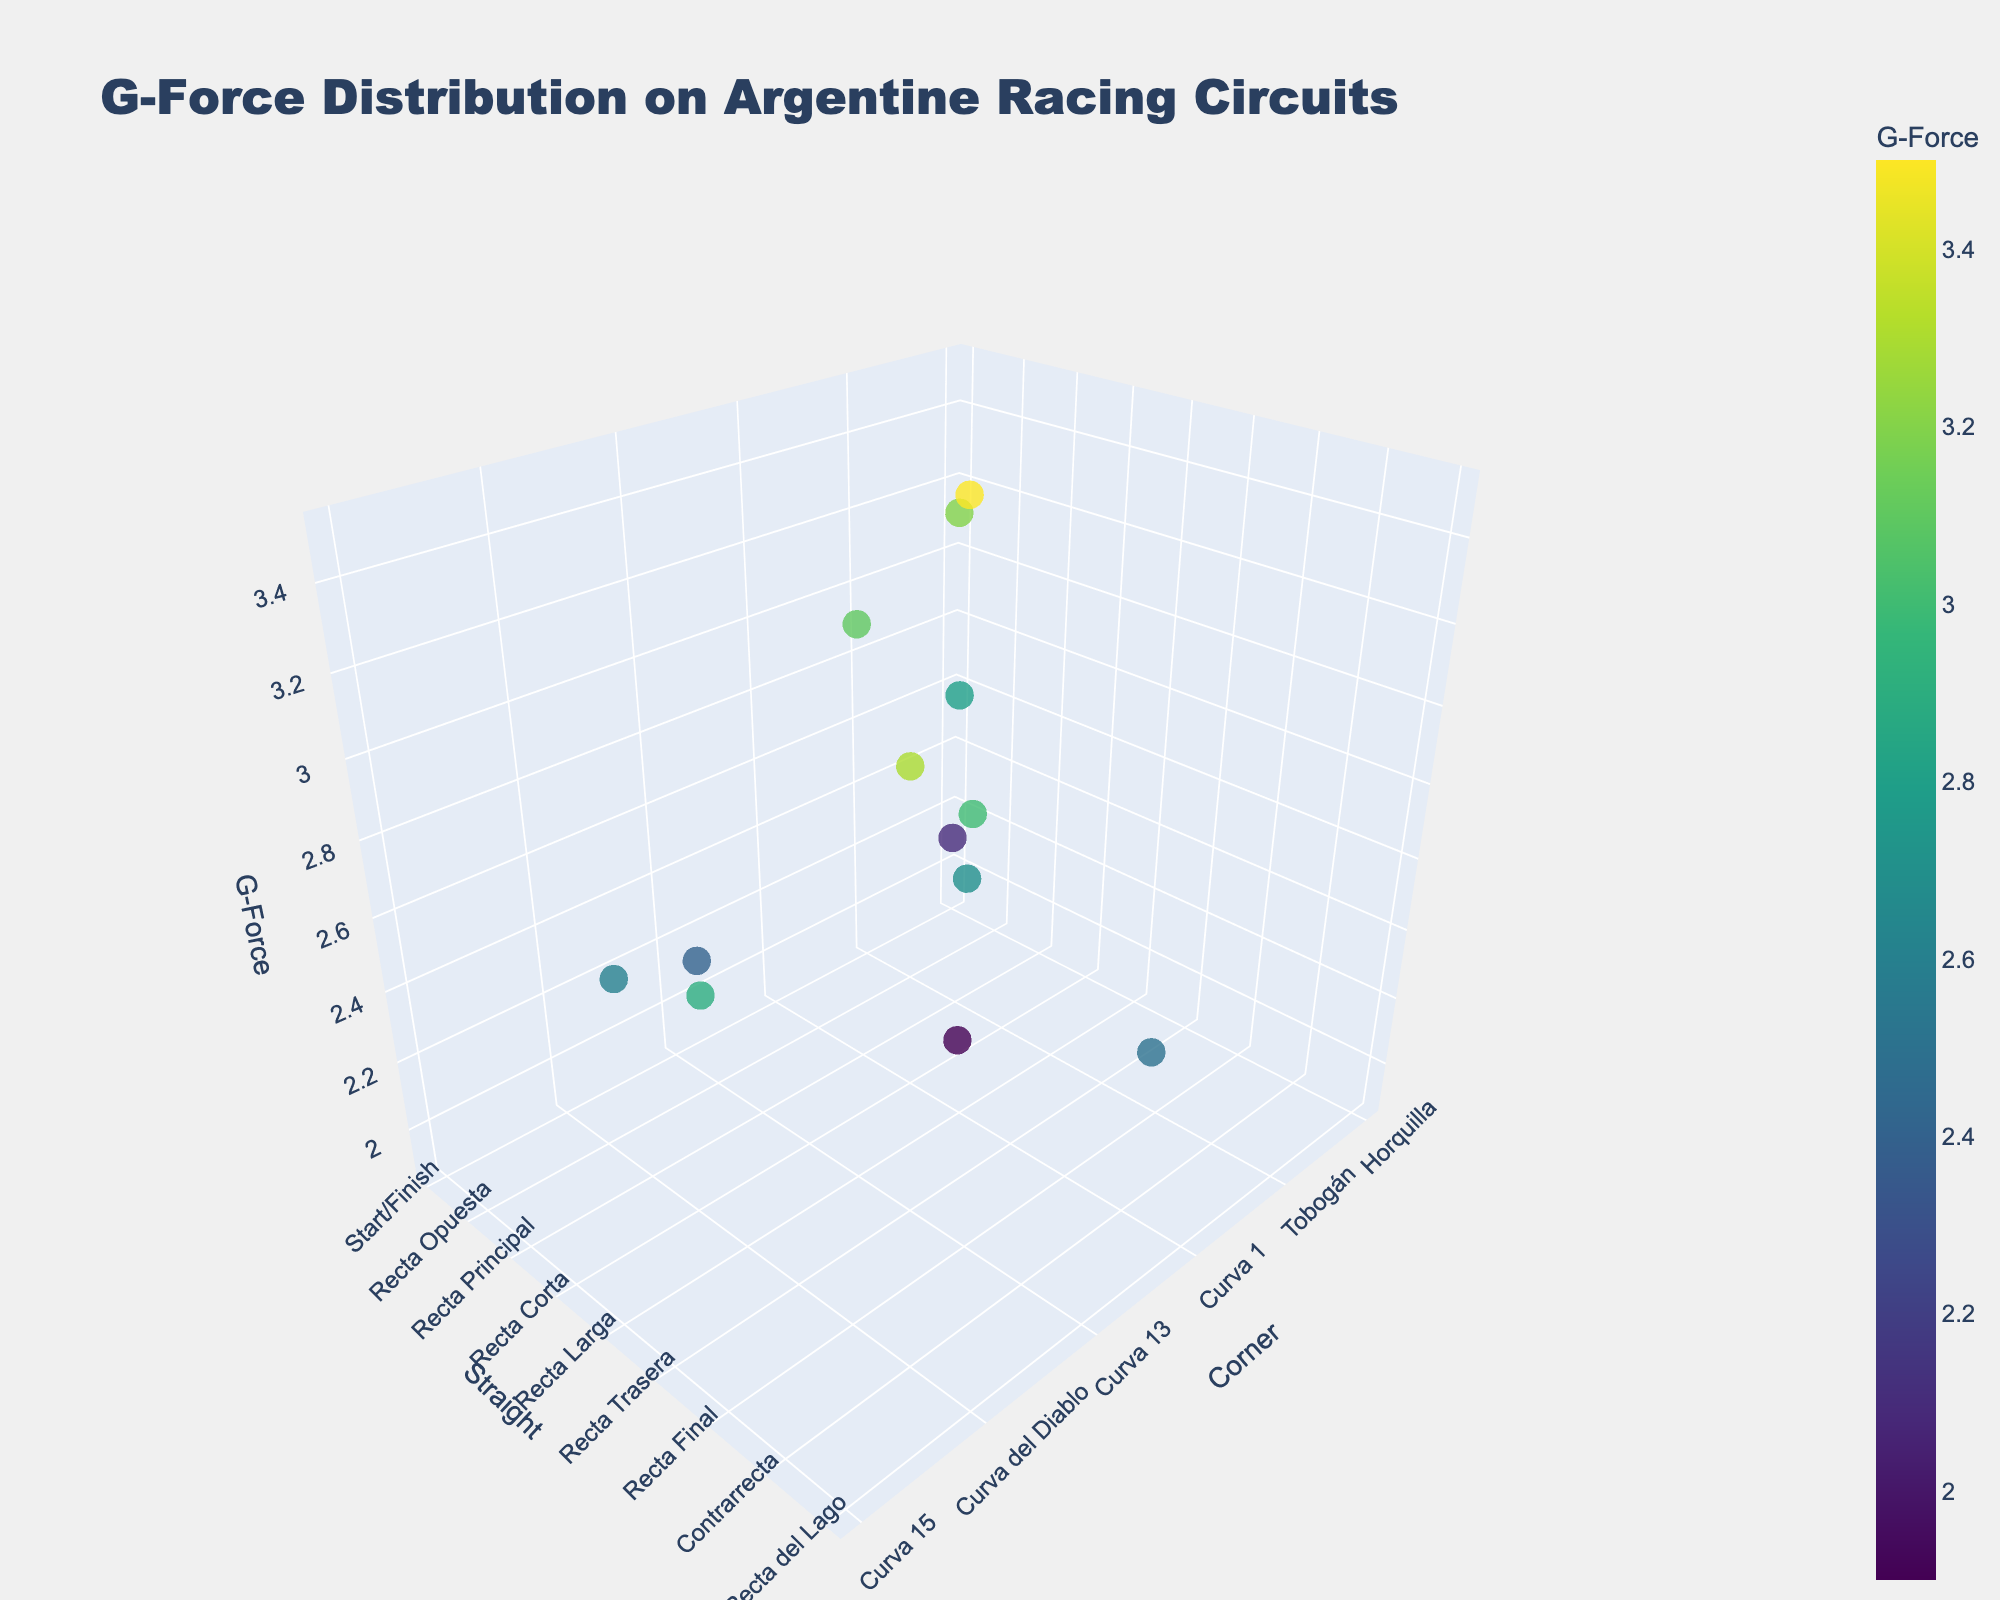What's the title of the figure? The title of the figure is located at the top center of the plot and it reads "G-Force Distribution on Argentine Racing Circuits".
Answer: G-Force Distribution on Argentine Racing Circuits How many circuits are displayed in the figure? By looking at the hover text on different points, we see that the circuits mentioned are Autódromo Oscar y Juan Gálvez, Autódromo Termas de Río Hondo, Autódromo Ciudad de La Rioja, and Autódromo Potrero de los Funes. Counting these gives us four circuits.
Answer: Four What's the highest G-Force value recorded and at which circuit and corner was it experienced? The highest G-Force value can be identified by the tallest point in the z-axis. Hovering over that point tells us it is 3.5 G at the Curva 1 on Autódromo Termas de Río Hondo.
Answer: 3.5 G at Curva 1, Autódromo Termas de Río Hondo Which corner and straight have the lowest G-Force value and which circuit is it on? The shortest point on the z-axis represents the lowest G-Force value. Hovering over that point shows it is 1.9 G experienced at Ese del Lago on the Straight Recta Corta at Autódromo Oscar y Juan Gálvez.
Answer: Ese del Lago and Recta Corta at Autódromo Oscar y Juan Gálvez What is the difference between the highest and lowest G-Force values recorded? To find the difference, subtract the lowest G-Force value from the highest G-Force value. The highest is 3.5 G and the lowest is 1.9 G, so the difference is 3.5 - 1.9.
Answer: 1.6 G Which circuit has the most varied range of G-Force values? To determine this, compare the range (difference between the highest and lowest G-Force values) for each circuit. The calculations are:
- Autódromo Oscar y Juan Gálvez: 3.2 - 1.9 = 1.3
- Autódromo Termas de Río Hondo: 3.5 - 2.7 = 0.8
- Autódromo Ciudad de La Rioja: 3.3 - 2.4 = 0.9
- Autódromo Potrero de los Funes: 3.1 - 2.5 = 0.6
Autódromo Oscar y Juan Gálvez has the largest range.
Answer: Autódromo Oscar y Juan Gálvez What is the average G-Force value for corners on Autódromo Oscar y Juan Gálvez? Sum all the G-Force values for corners at this circuit and divide by the number of corners. The G-Force values are 2.1, 3.2, 2.8, and 1.9. So, (2.1 + 3.2 + 2.8 + 1.9) / 4 = 10 / 4.
Answer: 2.5 G Which circuit and corresponding corner-straight pair experience a G-Force of exactly 2.4? Hover over the points and find the one with a G-Force value of 2.4. It is experienced at Curva del Tanque on Recta Principal at Autódromo Ciudad de La Rioja.
Answer: Curva del Tanque, Recta Principal at Autódromo Ciudad de La Rioja Does Autódromo Potrero de los Funes have a data point with a G-Force greater than 3.0 G? By looking at the points related to Autódromo Potrero de los Funes in the plot, the G-Force values are 3.1, 2.5, and 2.9. The value 3.1 G is indeed greater than 3.0 G.
Answer: Yes 